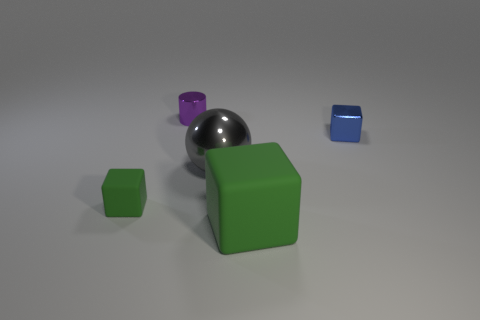Do the green block on the right side of the purple cylinder and the tiny thing that is on the right side of the gray metallic thing have the same material? Based on the visual analysis of the image, the green block on the right side of the purple cylinder and the tiny blue block on the right side of the gray metallic sphere do not appear to have the same material. The green block has a matte surface with a diffuse reflection which indicates it might be made of a plastic or painted wood, while the blue block has a shinier, more reflective surface suggesting a different material, possibly a type of polished metal or a coated object. 